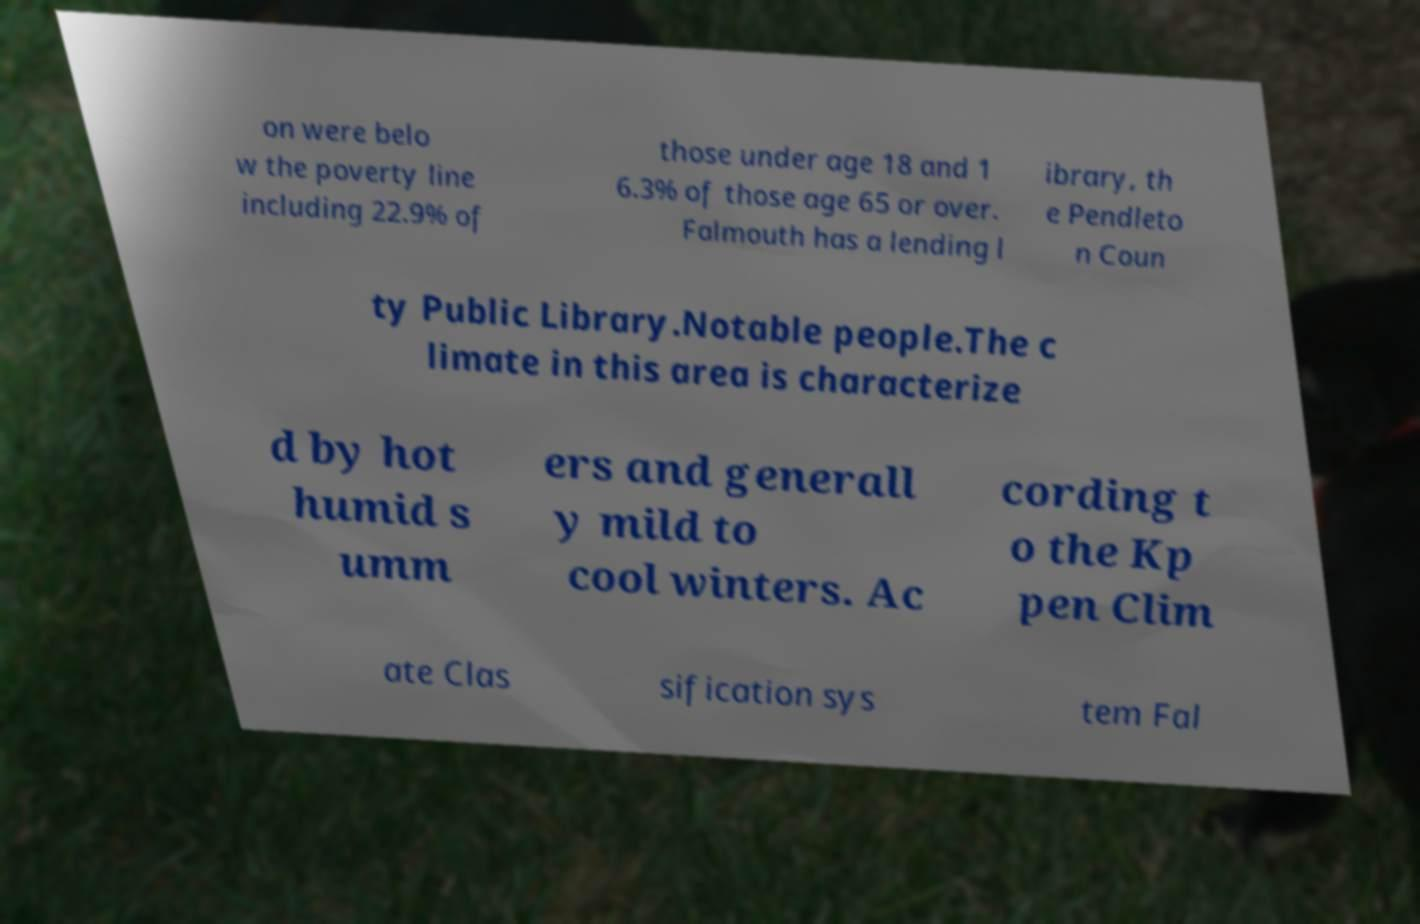I need the written content from this picture converted into text. Can you do that? on were belo w the poverty line including 22.9% of those under age 18 and 1 6.3% of those age 65 or over. Falmouth has a lending l ibrary, th e Pendleto n Coun ty Public Library.Notable people.The c limate in this area is characterize d by hot humid s umm ers and generall y mild to cool winters. Ac cording t o the Kp pen Clim ate Clas sification sys tem Fal 